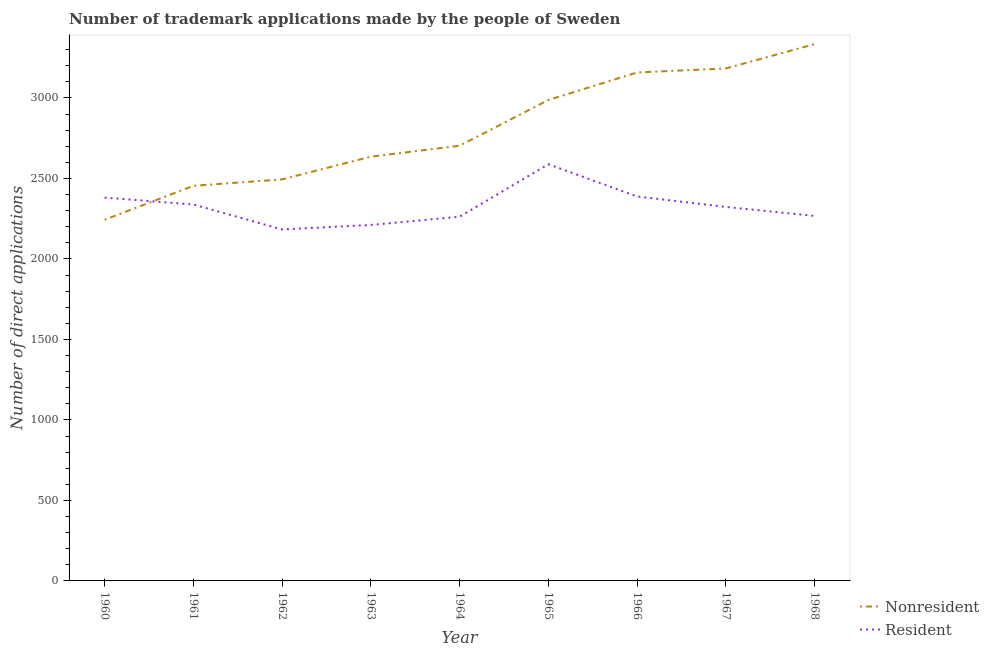How many different coloured lines are there?
Offer a terse response. 2. Is the number of lines equal to the number of legend labels?
Your answer should be compact. Yes. What is the number of trademark applications made by non residents in 1961?
Offer a terse response. 2454. Across all years, what is the maximum number of trademark applications made by non residents?
Give a very brief answer. 3334. Across all years, what is the minimum number of trademark applications made by residents?
Provide a succinct answer. 2183. In which year was the number of trademark applications made by non residents maximum?
Offer a terse response. 1968. In which year was the number of trademark applications made by non residents minimum?
Provide a succinct answer. 1960. What is the total number of trademark applications made by non residents in the graph?
Give a very brief answer. 2.52e+04. What is the difference between the number of trademark applications made by non residents in 1961 and that in 1963?
Keep it short and to the point. -181. What is the difference between the number of trademark applications made by non residents in 1965 and the number of trademark applications made by residents in 1962?
Make the answer very short. 804. What is the average number of trademark applications made by non residents per year?
Your response must be concise. 2799. In the year 1961, what is the difference between the number of trademark applications made by non residents and number of trademark applications made by residents?
Give a very brief answer. 116. What is the ratio of the number of trademark applications made by non residents in 1961 to that in 1963?
Offer a very short reply. 0.93. Is the number of trademark applications made by non residents in 1965 less than that in 1967?
Your answer should be very brief. Yes. Is the difference between the number of trademark applications made by residents in 1961 and 1968 greater than the difference between the number of trademark applications made by non residents in 1961 and 1968?
Keep it short and to the point. Yes. What is the difference between the highest and the second highest number of trademark applications made by residents?
Your answer should be compact. 200. What is the difference between the highest and the lowest number of trademark applications made by non residents?
Provide a succinct answer. 1091. Is the sum of the number of trademark applications made by residents in 1962 and 1968 greater than the maximum number of trademark applications made by non residents across all years?
Provide a succinct answer. Yes. Does the number of trademark applications made by non residents monotonically increase over the years?
Keep it short and to the point. Yes. Is the number of trademark applications made by residents strictly greater than the number of trademark applications made by non residents over the years?
Keep it short and to the point. No. How many lines are there?
Provide a succinct answer. 2. Are the values on the major ticks of Y-axis written in scientific E-notation?
Give a very brief answer. No. Does the graph contain grids?
Provide a short and direct response. No. Where does the legend appear in the graph?
Make the answer very short. Bottom right. What is the title of the graph?
Offer a very short reply. Number of trademark applications made by the people of Sweden. What is the label or title of the Y-axis?
Provide a succinct answer. Number of direct applications. What is the Number of direct applications in Nonresident in 1960?
Provide a short and direct response. 2243. What is the Number of direct applications in Resident in 1960?
Ensure brevity in your answer.  2381. What is the Number of direct applications in Nonresident in 1961?
Your answer should be very brief. 2454. What is the Number of direct applications of Resident in 1961?
Keep it short and to the point. 2338. What is the Number of direct applications in Nonresident in 1962?
Give a very brief answer. 2494. What is the Number of direct applications of Resident in 1962?
Provide a succinct answer. 2183. What is the Number of direct applications of Nonresident in 1963?
Your answer should be very brief. 2635. What is the Number of direct applications of Resident in 1963?
Provide a succinct answer. 2211. What is the Number of direct applications in Nonresident in 1964?
Your answer should be very brief. 2703. What is the Number of direct applications in Resident in 1964?
Your response must be concise. 2262. What is the Number of direct applications of Nonresident in 1965?
Provide a succinct answer. 2987. What is the Number of direct applications in Resident in 1965?
Make the answer very short. 2588. What is the Number of direct applications in Nonresident in 1966?
Keep it short and to the point. 3158. What is the Number of direct applications of Resident in 1966?
Keep it short and to the point. 2388. What is the Number of direct applications of Nonresident in 1967?
Keep it short and to the point. 3183. What is the Number of direct applications in Resident in 1967?
Ensure brevity in your answer.  2323. What is the Number of direct applications of Nonresident in 1968?
Offer a terse response. 3334. What is the Number of direct applications in Resident in 1968?
Your answer should be very brief. 2267. Across all years, what is the maximum Number of direct applications in Nonresident?
Your response must be concise. 3334. Across all years, what is the maximum Number of direct applications in Resident?
Give a very brief answer. 2588. Across all years, what is the minimum Number of direct applications of Nonresident?
Your response must be concise. 2243. Across all years, what is the minimum Number of direct applications in Resident?
Give a very brief answer. 2183. What is the total Number of direct applications of Nonresident in the graph?
Make the answer very short. 2.52e+04. What is the total Number of direct applications in Resident in the graph?
Make the answer very short. 2.09e+04. What is the difference between the Number of direct applications of Nonresident in 1960 and that in 1961?
Your answer should be compact. -211. What is the difference between the Number of direct applications in Nonresident in 1960 and that in 1962?
Provide a short and direct response. -251. What is the difference between the Number of direct applications of Resident in 1960 and that in 1962?
Your answer should be very brief. 198. What is the difference between the Number of direct applications in Nonresident in 1960 and that in 1963?
Offer a terse response. -392. What is the difference between the Number of direct applications of Resident in 1960 and that in 1963?
Your answer should be very brief. 170. What is the difference between the Number of direct applications in Nonresident in 1960 and that in 1964?
Make the answer very short. -460. What is the difference between the Number of direct applications of Resident in 1960 and that in 1964?
Your response must be concise. 119. What is the difference between the Number of direct applications of Nonresident in 1960 and that in 1965?
Keep it short and to the point. -744. What is the difference between the Number of direct applications of Resident in 1960 and that in 1965?
Provide a short and direct response. -207. What is the difference between the Number of direct applications of Nonresident in 1960 and that in 1966?
Provide a succinct answer. -915. What is the difference between the Number of direct applications in Resident in 1960 and that in 1966?
Provide a succinct answer. -7. What is the difference between the Number of direct applications in Nonresident in 1960 and that in 1967?
Your response must be concise. -940. What is the difference between the Number of direct applications of Nonresident in 1960 and that in 1968?
Offer a terse response. -1091. What is the difference between the Number of direct applications in Resident in 1960 and that in 1968?
Your answer should be very brief. 114. What is the difference between the Number of direct applications in Nonresident in 1961 and that in 1962?
Your response must be concise. -40. What is the difference between the Number of direct applications of Resident in 1961 and that in 1962?
Give a very brief answer. 155. What is the difference between the Number of direct applications in Nonresident in 1961 and that in 1963?
Give a very brief answer. -181. What is the difference between the Number of direct applications of Resident in 1961 and that in 1963?
Give a very brief answer. 127. What is the difference between the Number of direct applications of Nonresident in 1961 and that in 1964?
Your response must be concise. -249. What is the difference between the Number of direct applications of Resident in 1961 and that in 1964?
Provide a succinct answer. 76. What is the difference between the Number of direct applications of Nonresident in 1961 and that in 1965?
Your response must be concise. -533. What is the difference between the Number of direct applications in Resident in 1961 and that in 1965?
Keep it short and to the point. -250. What is the difference between the Number of direct applications of Nonresident in 1961 and that in 1966?
Your answer should be very brief. -704. What is the difference between the Number of direct applications of Nonresident in 1961 and that in 1967?
Offer a terse response. -729. What is the difference between the Number of direct applications in Resident in 1961 and that in 1967?
Ensure brevity in your answer.  15. What is the difference between the Number of direct applications in Nonresident in 1961 and that in 1968?
Ensure brevity in your answer.  -880. What is the difference between the Number of direct applications of Resident in 1961 and that in 1968?
Offer a terse response. 71. What is the difference between the Number of direct applications of Nonresident in 1962 and that in 1963?
Provide a short and direct response. -141. What is the difference between the Number of direct applications of Resident in 1962 and that in 1963?
Ensure brevity in your answer.  -28. What is the difference between the Number of direct applications of Nonresident in 1962 and that in 1964?
Provide a short and direct response. -209. What is the difference between the Number of direct applications of Resident in 1962 and that in 1964?
Your answer should be compact. -79. What is the difference between the Number of direct applications of Nonresident in 1962 and that in 1965?
Provide a short and direct response. -493. What is the difference between the Number of direct applications of Resident in 1962 and that in 1965?
Make the answer very short. -405. What is the difference between the Number of direct applications in Nonresident in 1962 and that in 1966?
Your answer should be very brief. -664. What is the difference between the Number of direct applications in Resident in 1962 and that in 1966?
Keep it short and to the point. -205. What is the difference between the Number of direct applications of Nonresident in 1962 and that in 1967?
Provide a short and direct response. -689. What is the difference between the Number of direct applications in Resident in 1962 and that in 1967?
Keep it short and to the point. -140. What is the difference between the Number of direct applications in Nonresident in 1962 and that in 1968?
Offer a terse response. -840. What is the difference between the Number of direct applications in Resident in 1962 and that in 1968?
Your answer should be very brief. -84. What is the difference between the Number of direct applications in Nonresident in 1963 and that in 1964?
Provide a short and direct response. -68. What is the difference between the Number of direct applications of Resident in 1963 and that in 1964?
Offer a terse response. -51. What is the difference between the Number of direct applications in Nonresident in 1963 and that in 1965?
Your answer should be compact. -352. What is the difference between the Number of direct applications in Resident in 1963 and that in 1965?
Offer a terse response. -377. What is the difference between the Number of direct applications in Nonresident in 1963 and that in 1966?
Keep it short and to the point. -523. What is the difference between the Number of direct applications in Resident in 1963 and that in 1966?
Your response must be concise. -177. What is the difference between the Number of direct applications of Nonresident in 1963 and that in 1967?
Provide a succinct answer. -548. What is the difference between the Number of direct applications of Resident in 1963 and that in 1967?
Offer a very short reply. -112. What is the difference between the Number of direct applications in Nonresident in 1963 and that in 1968?
Provide a succinct answer. -699. What is the difference between the Number of direct applications in Resident in 1963 and that in 1968?
Provide a short and direct response. -56. What is the difference between the Number of direct applications in Nonresident in 1964 and that in 1965?
Provide a short and direct response. -284. What is the difference between the Number of direct applications of Resident in 1964 and that in 1965?
Your answer should be compact. -326. What is the difference between the Number of direct applications of Nonresident in 1964 and that in 1966?
Make the answer very short. -455. What is the difference between the Number of direct applications in Resident in 1964 and that in 1966?
Make the answer very short. -126. What is the difference between the Number of direct applications in Nonresident in 1964 and that in 1967?
Your answer should be very brief. -480. What is the difference between the Number of direct applications of Resident in 1964 and that in 1967?
Ensure brevity in your answer.  -61. What is the difference between the Number of direct applications of Nonresident in 1964 and that in 1968?
Your response must be concise. -631. What is the difference between the Number of direct applications in Resident in 1964 and that in 1968?
Your response must be concise. -5. What is the difference between the Number of direct applications in Nonresident in 1965 and that in 1966?
Provide a succinct answer. -171. What is the difference between the Number of direct applications of Resident in 1965 and that in 1966?
Provide a succinct answer. 200. What is the difference between the Number of direct applications of Nonresident in 1965 and that in 1967?
Offer a very short reply. -196. What is the difference between the Number of direct applications in Resident in 1965 and that in 1967?
Ensure brevity in your answer.  265. What is the difference between the Number of direct applications in Nonresident in 1965 and that in 1968?
Your response must be concise. -347. What is the difference between the Number of direct applications of Resident in 1965 and that in 1968?
Give a very brief answer. 321. What is the difference between the Number of direct applications of Nonresident in 1966 and that in 1967?
Offer a terse response. -25. What is the difference between the Number of direct applications of Resident in 1966 and that in 1967?
Offer a very short reply. 65. What is the difference between the Number of direct applications in Nonresident in 1966 and that in 1968?
Offer a very short reply. -176. What is the difference between the Number of direct applications of Resident in 1966 and that in 1968?
Provide a short and direct response. 121. What is the difference between the Number of direct applications of Nonresident in 1967 and that in 1968?
Your answer should be very brief. -151. What is the difference between the Number of direct applications of Resident in 1967 and that in 1968?
Provide a short and direct response. 56. What is the difference between the Number of direct applications in Nonresident in 1960 and the Number of direct applications in Resident in 1961?
Make the answer very short. -95. What is the difference between the Number of direct applications of Nonresident in 1960 and the Number of direct applications of Resident in 1965?
Give a very brief answer. -345. What is the difference between the Number of direct applications of Nonresident in 1960 and the Number of direct applications of Resident in 1966?
Keep it short and to the point. -145. What is the difference between the Number of direct applications of Nonresident in 1960 and the Number of direct applications of Resident in 1967?
Provide a succinct answer. -80. What is the difference between the Number of direct applications in Nonresident in 1961 and the Number of direct applications in Resident in 1962?
Make the answer very short. 271. What is the difference between the Number of direct applications in Nonresident in 1961 and the Number of direct applications in Resident in 1963?
Ensure brevity in your answer.  243. What is the difference between the Number of direct applications in Nonresident in 1961 and the Number of direct applications in Resident in 1964?
Ensure brevity in your answer.  192. What is the difference between the Number of direct applications of Nonresident in 1961 and the Number of direct applications of Resident in 1965?
Your answer should be very brief. -134. What is the difference between the Number of direct applications of Nonresident in 1961 and the Number of direct applications of Resident in 1967?
Your answer should be compact. 131. What is the difference between the Number of direct applications of Nonresident in 1961 and the Number of direct applications of Resident in 1968?
Offer a terse response. 187. What is the difference between the Number of direct applications in Nonresident in 1962 and the Number of direct applications in Resident in 1963?
Provide a succinct answer. 283. What is the difference between the Number of direct applications of Nonresident in 1962 and the Number of direct applications of Resident in 1964?
Offer a very short reply. 232. What is the difference between the Number of direct applications in Nonresident in 1962 and the Number of direct applications in Resident in 1965?
Offer a very short reply. -94. What is the difference between the Number of direct applications in Nonresident in 1962 and the Number of direct applications in Resident in 1966?
Provide a succinct answer. 106. What is the difference between the Number of direct applications in Nonresident in 1962 and the Number of direct applications in Resident in 1967?
Offer a very short reply. 171. What is the difference between the Number of direct applications of Nonresident in 1962 and the Number of direct applications of Resident in 1968?
Give a very brief answer. 227. What is the difference between the Number of direct applications in Nonresident in 1963 and the Number of direct applications in Resident in 1964?
Ensure brevity in your answer.  373. What is the difference between the Number of direct applications in Nonresident in 1963 and the Number of direct applications in Resident in 1965?
Provide a short and direct response. 47. What is the difference between the Number of direct applications of Nonresident in 1963 and the Number of direct applications of Resident in 1966?
Offer a terse response. 247. What is the difference between the Number of direct applications of Nonresident in 1963 and the Number of direct applications of Resident in 1967?
Your answer should be compact. 312. What is the difference between the Number of direct applications of Nonresident in 1963 and the Number of direct applications of Resident in 1968?
Offer a terse response. 368. What is the difference between the Number of direct applications in Nonresident in 1964 and the Number of direct applications in Resident in 1965?
Your answer should be very brief. 115. What is the difference between the Number of direct applications in Nonresident in 1964 and the Number of direct applications in Resident in 1966?
Ensure brevity in your answer.  315. What is the difference between the Number of direct applications in Nonresident in 1964 and the Number of direct applications in Resident in 1967?
Provide a short and direct response. 380. What is the difference between the Number of direct applications of Nonresident in 1964 and the Number of direct applications of Resident in 1968?
Offer a terse response. 436. What is the difference between the Number of direct applications of Nonresident in 1965 and the Number of direct applications of Resident in 1966?
Your answer should be compact. 599. What is the difference between the Number of direct applications of Nonresident in 1965 and the Number of direct applications of Resident in 1967?
Your response must be concise. 664. What is the difference between the Number of direct applications in Nonresident in 1965 and the Number of direct applications in Resident in 1968?
Provide a short and direct response. 720. What is the difference between the Number of direct applications in Nonresident in 1966 and the Number of direct applications in Resident in 1967?
Your answer should be compact. 835. What is the difference between the Number of direct applications of Nonresident in 1966 and the Number of direct applications of Resident in 1968?
Offer a very short reply. 891. What is the difference between the Number of direct applications in Nonresident in 1967 and the Number of direct applications in Resident in 1968?
Give a very brief answer. 916. What is the average Number of direct applications of Nonresident per year?
Provide a short and direct response. 2799. What is the average Number of direct applications of Resident per year?
Offer a very short reply. 2326.78. In the year 1960, what is the difference between the Number of direct applications of Nonresident and Number of direct applications of Resident?
Make the answer very short. -138. In the year 1961, what is the difference between the Number of direct applications of Nonresident and Number of direct applications of Resident?
Offer a terse response. 116. In the year 1962, what is the difference between the Number of direct applications of Nonresident and Number of direct applications of Resident?
Offer a terse response. 311. In the year 1963, what is the difference between the Number of direct applications of Nonresident and Number of direct applications of Resident?
Provide a short and direct response. 424. In the year 1964, what is the difference between the Number of direct applications in Nonresident and Number of direct applications in Resident?
Provide a succinct answer. 441. In the year 1965, what is the difference between the Number of direct applications in Nonresident and Number of direct applications in Resident?
Your response must be concise. 399. In the year 1966, what is the difference between the Number of direct applications of Nonresident and Number of direct applications of Resident?
Keep it short and to the point. 770. In the year 1967, what is the difference between the Number of direct applications in Nonresident and Number of direct applications in Resident?
Give a very brief answer. 860. In the year 1968, what is the difference between the Number of direct applications of Nonresident and Number of direct applications of Resident?
Keep it short and to the point. 1067. What is the ratio of the Number of direct applications in Nonresident in 1960 to that in 1961?
Your response must be concise. 0.91. What is the ratio of the Number of direct applications of Resident in 1960 to that in 1961?
Give a very brief answer. 1.02. What is the ratio of the Number of direct applications in Nonresident in 1960 to that in 1962?
Keep it short and to the point. 0.9. What is the ratio of the Number of direct applications of Resident in 1960 to that in 1962?
Make the answer very short. 1.09. What is the ratio of the Number of direct applications in Nonresident in 1960 to that in 1963?
Make the answer very short. 0.85. What is the ratio of the Number of direct applications in Resident in 1960 to that in 1963?
Your answer should be very brief. 1.08. What is the ratio of the Number of direct applications of Nonresident in 1960 to that in 1964?
Provide a succinct answer. 0.83. What is the ratio of the Number of direct applications in Resident in 1960 to that in 1964?
Your response must be concise. 1.05. What is the ratio of the Number of direct applications in Nonresident in 1960 to that in 1965?
Offer a terse response. 0.75. What is the ratio of the Number of direct applications in Resident in 1960 to that in 1965?
Make the answer very short. 0.92. What is the ratio of the Number of direct applications in Nonresident in 1960 to that in 1966?
Offer a very short reply. 0.71. What is the ratio of the Number of direct applications in Nonresident in 1960 to that in 1967?
Provide a short and direct response. 0.7. What is the ratio of the Number of direct applications in Nonresident in 1960 to that in 1968?
Give a very brief answer. 0.67. What is the ratio of the Number of direct applications in Resident in 1960 to that in 1968?
Provide a short and direct response. 1.05. What is the ratio of the Number of direct applications of Resident in 1961 to that in 1962?
Offer a terse response. 1.07. What is the ratio of the Number of direct applications in Nonresident in 1961 to that in 1963?
Keep it short and to the point. 0.93. What is the ratio of the Number of direct applications in Resident in 1961 to that in 1963?
Your answer should be compact. 1.06. What is the ratio of the Number of direct applications of Nonresident in 1961 to that in 1964?
Your answer should be very brief. 0.91. What is the ratio of the Number of direct applications of Resident in 1961 to that in 1964?
Ensure brevity in your answer.  1.03. What is the ratio of the Number of direct applications of Nonresident in 1961 to that in 1965?
Give a very brief answer. 0.82. What is the ratio of the Number of direct applications of Resident in 1961 to that in 1965?
Offer a terse response. 0.9. What is the ratio of the Number of direct applications in Nonresident in 1961 to that in 1966?
Make the answer very short. 0.78. What is the ratio of the Number of direct applications of Resident in 1961 to that in 1966?
Ensure brevity in your answer.  0.98. What is the ratio of the Number of direct applications of Nonresident in 1961 to that in 1967?
Make the answer very short. 0.77. What is the ratio of the Number of direct applications in Nonresident in 1961 to that in 1968?
Your answer should be very brief. 0.74. What is the ratio of the Number of direct applications of Resident in 1961 to that in 1968?
Offer a terse response. 1.03. What is the ratio of the Number of direct applications of Nonresident in 1962 to that in 1963?
Keep it short and to the point. 0.95. What is the ratio of the Number of direct applications of Resident in 1962 to that in 1963?
Give a very brief answer. 0.99. What is the ratio of the Number of direct applications of Nonresident in 1962 to that in 1964?
Your answer should be very brief. 0.92. What is the ratio of the Number of direct applications of Resident in 1962 to that in 1964?
Ensure brevity in your answer.  0.97. What is the ratio of the Number of direct applications in Nonresident in 1962 to that in 1965?
Provide a succinct answer. 0.83. What is the ratio of the Number of direct applications in Resident in 1962 to that in 1965?
Provide a succinct answer. 0.84. What is the ratio of the Number of direct applications of Nonresident in 1962 to that in 1966?
Ensure brevity in your answer.  0.79. What is the ratio of the Number of direct applications in Resident in 1962 to that in 1966?
Offer a very short reply. 0.91. What is the ratio of the Number of direct applications of Nonresident in 1962 to that in 1967?
Offer a very short reply. 0.78. What is the ratio of the Number of direct applications in Resident in 1962 to that in 1967?
Keep it short and to the point. 0.94. What is the ratio of the Number of direct applications in Nonresident in 1962 to that in 1968?
Keep it short and to the point. 0.75. What is the ratio of the Number of direct applications of Resident in 1962 to that in 1968?
Make the answer very short. 0.96. What is the ratio of the Number of direct applications of Nonresident in 1963 to that in 1964?
Ensure brevity in your answer.  0.97. What is the ratio of the Number of direct applications of Resident in 1963 to that in 1964?
Keep it short and to the point. 0.98. What is the ratio of the Number of direct applications of Nonresident in 1963 to that in 1965?
Provide a short and direct response. 0.88. What is the ratio of the Number of direct applications in Resident in 1963 to that in 1965?
Provide a short and direct response. 0.85. What is the ratio of the Number of direct applications of Nonresident in 1963 to that in 1966?
Make the answer very short. 0.83. What is the ratio of the Number of direct applications of Resident in 1963 to that in 1966?
Give a very brief answer. 0.93. What is the ratio of the Number of direct applications in Nonresident in 1963 to that in 1967?
Ensure brevity in your answer.  0.83. What is the ratio of the Number of direct applications in Resident in 1963 to that in 1967?
Offer a terse response. 0.95. What is the ratio of the Number of direct applications of Nonresident in 1963 to that in 1968?
Make the answer very short. 0.79. What is the ratio of the Number of direct applications in Resident in 1963 to that in 1968?
Provide a short and direct response. 0.98. What is the ratio of the Number of direct applications in Nonresident in 1964 to that in 1965?
Your response must be concise. 0.9. What is the ratio of the Number of direct applications in Resident in 1964 to that in 1965?
Make the answer very short. 0.87. What is the ratio of the Number of direct applications in Nonresident in 1964 to that in 1966?
Give a very brief answer. 0.86. What is the ratio of the Number of direct applications in Resident in 1964 to that in 1966?
Provide a short and direct response. 0.95. What is the ratio of the Number of direct applications in Nonresident in 1964 to that in 1967?
Provide a succinct answer. 0.85. What is the ratio of the Number of direct applications in Resident in 1964 to that in 1967?
Make the answer very short. 0.97. What is the ratio of the Number of direct applications in Nonresident in 1964 to that in 1968?
Keep it short and to the point. 0.81. What is the ratio of the Number of direct applications of Resident in 1964 to that in 1968?
Ensure brevity in your answer.  1. What is the ratio of the Number of direct applications of Nonresident in 1965 to that in 1966?
Your response must be concise. 0.95. What is the ratio of the Number of direct applications in Resident in 1965 to that in 1966?
Provide a short and direct response. 1.08. What is the ratio of the Number of direct applications in Nonresident in 1965 to that in 1967?
Your answer should be very brief. 0.94. What is the ratio of the Number of direct applications in Resident in 1965 to that in 1967?
Offer a very short reply. 1.11. What is the ratio of the Number of direct applications of Nonresident in 1965 to that in 1968?
Your answer should be compact. 0.9. What is the ratio of the Number of direct applications in Resident in 1965 to that in 1968?
Offer a terse response. 1.14. What is the ratio of the Number of direct applications in Nonresident in 1966 to that in 1967?
Make the answer very short. 0.99. What is the ratio of the Number of direct applications in Resident in 1966 to that in 1967?
Make the answer very short. 1.03. What is the ratio of the Number of direct applications of Nonresident in 1966 to that in 1968?
Provide a succinct answer. 0.95. What is the ratio of the Number of direct applications in Resident in 1966 to that in 1968?
Offer a very short reply. 1.05. What is the ratio of the Number of direct applications in Nonresident in 1967 to that in 1968?
Provide a short and direct response. 0.95. What is the ratio of the Number of direct applications in Resident in 1967 to that in 1968?
Keep it short and to the point. 1.02. What is the difference between the highest and the second highest Number of direct applications in Nonresident?
Provide a succinct answer. 151. What is the difference between the highest and the second highest Number of direct applications of Resident?
Your answer should be very brief. 200. What is the difference between the highest and the lowest Number of direct applications of Nonresident?
Make the answer very short. 1091. What is the difference between the highest and the lowest Number of direct applications of Resident?
Keep it short and to the point. 405. 